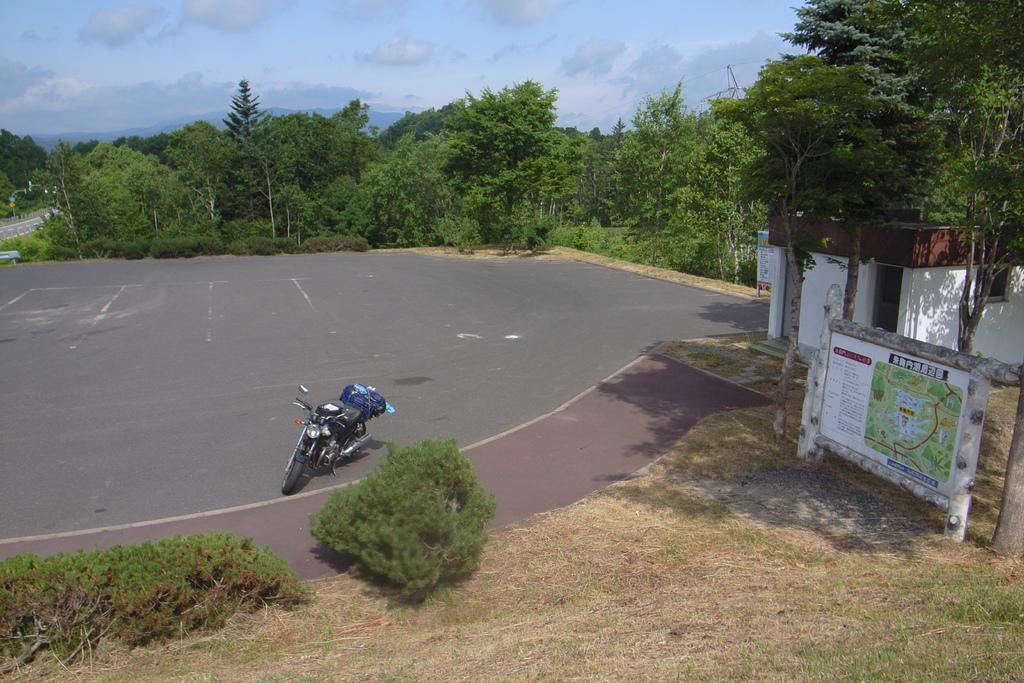Describe this image in one or two sentences. In this image I can see the bike on the road. To the side of the bike I can see the plants. To the right there is a board and the house. In the back there are many trees, clouds and the sky. 